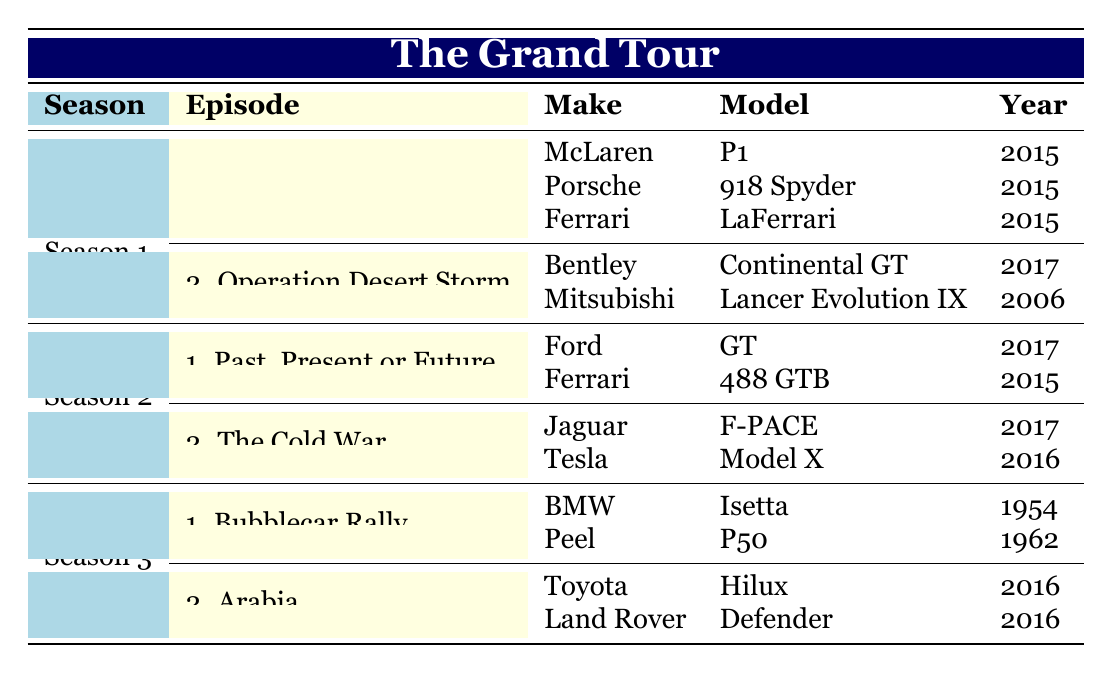What car model did Ferrari feature in Season 1, Episode 1? In Season 1, Episode 1 titled "The Holy Trinity," Ferrari is listed as featuring the LaFerrari model from 2015.
Answer: LaFerrari Which episode features the Bentley Continental GT? The Bentley Continental GT appears in Season 1, Episode 2, titled "Operation Desert Storm."
Answer: Episode 2 How many car models are featured in total across all episodes? Counting the car models listed in the table, there are 10 models in total: 3 in Episode 1 (Season 1) + 2 in Episode 2 (Season 1) + 2 in Episode 1 (Season 2) + 2 in Episode 2 (Season 2) + 2 in Episode 1 (Season 3) + 2 in Episode 2 (Season 3) = 10 models.
Answer: 10 Is the Ford GT featured in Season 3? Checking the table, the Ford GT is listed in Season 2, Episode 1, not in Season 3, hence the statement is false.
Answer: No What is the average production year of the car models featured in Season 2? The car models for Season 2 are Ford GT (2017), Ferrari 488 GTB (2015), Jaguar F-PACE (2017), and Tesla Model X (2016). Adding the years (2017 + 2015 + 2017 + 2016 = 66) and dividing by the number of models (4) gives an average year of 16.5, which is 2016.
Answer: 2016 Which make features a model from the year 2006 in Season 1? Referring to the table, the Mitsubishi Lancer Evolution IX from 2006 is featured in Season 1, Episode 2.
Answer: Mitsubishi How many different makes of cars are featured in Season 1? In Season 1, there are 5 different makes: McLaren, Porsche, Ferrari, Bentley, and Mitsubishi. This is determined by counting the unique makes listed in the episodes of Season 1.
Answer: 5 Are there any car models featured in Season 3 that were also in Season 1? Comparing both seasons, there are no models repeated. The models in Season 3 (BMW Isetta, Peel P50, Toyota Hilux, and Land Rover Defender) do not appear in Season 1.
Answer: No 